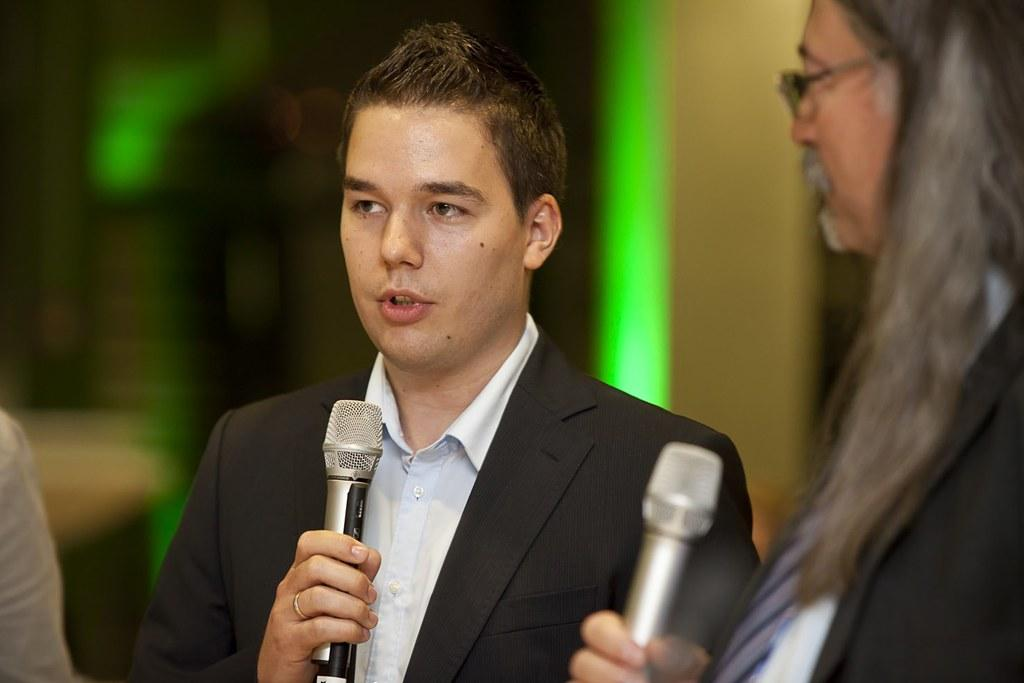What is the man in the image wearing? The man is wearing a suit in the image. What is the man holding in the image? The man is holding a microphone in the image. What is the man doing with the microphone? The man is talking in front of the microphone in the image. Who else is present in the image? There is another person standing beside the man in the image. What is the other person holding in the image? The other person is also holding a microphone in the image. What type of rings can be seen on the man's fingers in the image? There are no rings visible on the man's fingers in the image. What kind of wilderness can be seen in the background of the image? There is no wilderness present in the image; it appears to be an indoor setting. 